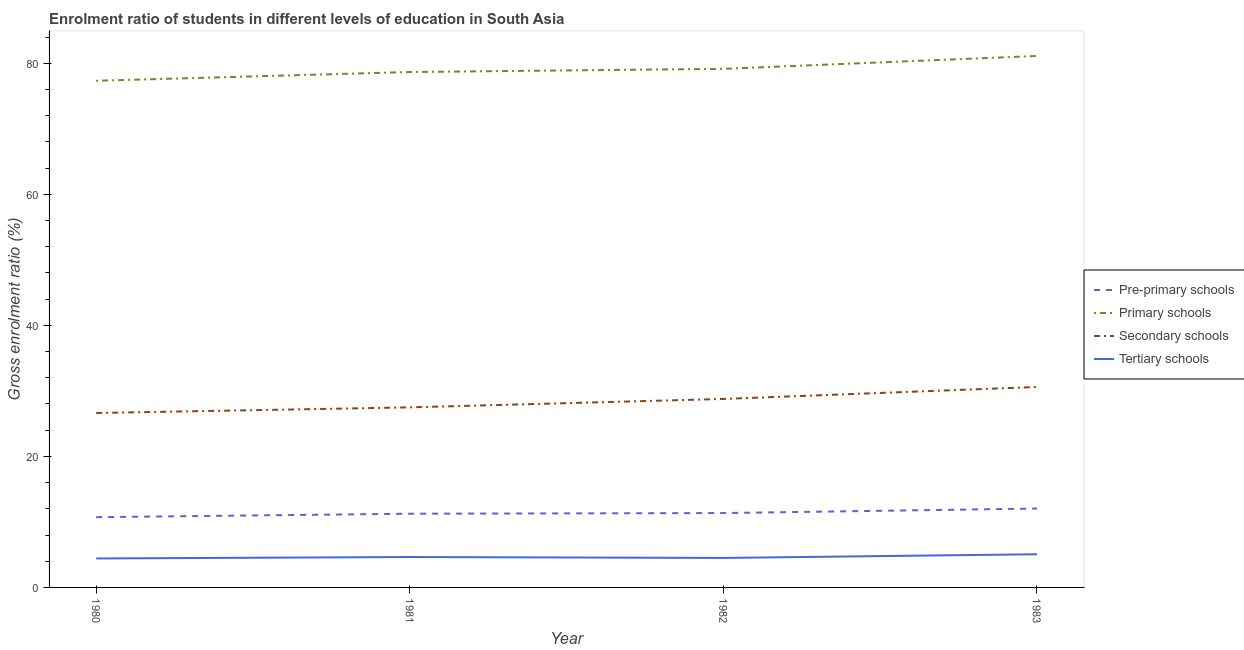Is the number of lines equal to the number of legend labels?
Provide a succinct answer. Yes. What is the gross enrolment ratio in tertiary schools in 1983?
Ensure brevity in your answer.  5.06. Across all years, what is the maximum gross enrolment ratio in primary schools?
Provide a short and direct response. 81.13. Across all years, what is the minimum gross enrolment ratio in secondary schools?
Your answer should be very brief. 26.62. In which year was the gross enrolment ratio in pre-primary schools minimum?
Keep it short and to the point. 1980. What is the total gross enrolment ratio in pre-primary schools in the graph?
Your answer should be very brief. 45.37. What is the difference between the gross enrolment ratio in secondary schools in 1981 and that in 1982?
Give a very brief answer. -1.29. What is the difference between the gross enrolment ratio in pre-primary schools in 1981 and the gross enrolment ratio in tertiary schools in 1980?
Ensure brevity in your answer.  6.83. What is the average gross enrolment ratio in primary schools per year?
Offer a terse response. 79.08. In the year 1981, what is the difference between the gross enrolment ratio in primary schools and gross enrolment ratio in pre-primary schools?
Ensure brevity in your answer.  67.42. In how many years, is the gross enrolment ratio in secondary schools greater than 48 %?
Offer a very short reply. 0. What is the ratio of the gross enrolment ratio in secondary schools in 1981 to that in 1983?
Your answer should be compact. 0.9. Is the difference between the gross enrolment ratio in pre-primary schools in 1980 and 1981 greater than the difference between the gross enrolment ratio in secondary schools in 1980 and 1981?
Make the answer very short. Yes. What is the difference between the highest and the second highest gross enrolment ratio in primary schools?
Offer a very short reply. 1.97. What is the difference between the highest and the lowest gross enrolment ratio in pre-primary schools?
Give a very brief answer. 1.32. Is the sum of the gross enrolment ratio in pre-primary schools in 1980 and 1982 greater than the maximum gross enrolment ratio in primary schools across all years?
Your answer should be compact. No. Is it the case that in every year, the sum of the gross enrolment ratio in pre-primary schools and gross enrolment ratio in primary schools is greater than the gross enrolment ratio in secondary schools?
Your response must be concise. Yes. Is the gross enrolment ratio in secondary schools strictly greater than the gross enrolment ratio in primary schools over the years?
Make the answer very short. No. Is the gross enrolment ratio in pre-primary schools strictly less than the gross enrolment ratio in secondary schools over the years?
Keep it short and to the point. Yes. How many lines are there?
Provide a succinct answer. 4. How many years are there in the graph?
Keep it short and to the point. 4. Are the values on the major ticks of Y-axis written in scientific E-notation?
Give a very brief answer. No. Does the graph contain grids?
Your answer should be compact. No. Where does the legend appear in the graph?
Make the answer very short. Center right. How many legend labels are there?
Your answer should be compact. 4. How are the legend labels stacked?
Your answer should be very brief. Vertical. What is the title of the graph?
Keep it short and to the point. Enrolment ratio of students in different levels of education in South Asia. Does "Source data assessment" appear as one of the legend labels in the graph?
Ensure brevity in your answer.  No. What is the Gross enrolment ratio (%) in Pre-primary schools in 1980?
Offer a very short reply. 10.72. What is the Gross enrolment ratio (%) of Primary schools in 1980?
Your response must be concise. 77.34. What is the Gross enrolment ratio (%) in Secondary schools in 1980?
Your response must be concise. 26.62. What is the Gross enrolment ratio (%) of Tertiary schools in 1980?
Make the answer very short. 4.42. What is the Gross enrolment ratio (%) in Pre-primary schools in 1981?
Ensure brevity in your answer.  11.25. What is the Gross enrolment ratio (%) of Primary schools in 1981?
Your response must be concise. 78.68. What is the Gross enrolment ratio (%) in Secondary schools in 1981?
Make the answer very short. 27.49. What is the Gross enrolment ratio (%) in Tertiary schools in 1981?
Keep it short and to the point. 4.64. What is the Gross enrolment ratio (%) in Pre-primary schools in 1982?
Give a very brief answer. 11.35. What is the Gross enrolment ratio (%) in Primary schools in 1982?
Make the answer very short. 79.16. What is the Gross enrolment ratio (%) in Secondary schools in 1982?
Ensure brevity in your answer.  28.77. What is the Gross enrolment ratio (%) in Tertiary schools in 1982?
Offer a very short reply. 4.5. What is the Gross enrolment ratio (%) in Pre-primary schools in 1983?
Make the answer very short. 12.04. What is the Gross enrolment ratio (%) of Primary schools in 1983?
Keep it short and to the point. 81.13. What is the Gross enrolment ratio (%) of Secondary schools in 1983?
Your response must be concise. 30.6. What is the Gross enrolment ratio (%) in Tertiary schools in 1983?
Provide a short and direct response. 5.06. Across all years, what is the maximum Gross enrolment ratio (%) of Pre-primary schools?
Ensure brevity in your answer.  12.04. Across all years, what is the maximum Gross enrolment ratio (%) in Primary schools?
Offer a terse response. 81.13. Across all years, what is the maximum Gross enrolment ratio (%) of Secondary schools?
Your response must be concise. 30.6. Across all years, what is the maximum Gross enrolment ratio (%) of Tertiary schools?
Your response must be concise. 5.06. Across all years, what is the minimum Gross enrolment ratio (%) in Pre-primary schools?
Offer a very short reply. 10.72. Across all years, what is the minimum Gross enrolment ratio (%) in Primary schools?
Offer a very short reply. 77.34. Across all years, what is the minimum Gross enrolment ratio (%) in Secondary schools?
Provide a succinct answer. 26.62. Across all years, what is the minimum Gross enrolment ratio (%) of Tertiary schools?
Your response must be concise. 4.42. What is the total Gross enrolment ratio (%) in Pre-primary schools in the graph?
Ensure brevity in your answer.  45.37. What is the total Gross enrolment ratio (%) of Primary schools in the graph?
Your answer should be very brief. 316.3. What is the total Gross enrolment ratio (%) of Secondary schools in the graph?
Provide a succinct answer. 113.49. What is the total Gross enrolment ratio (%) in Tertiary schools in the graph?
Offer a very short reply. 18.63. What is the difference between the Gross enrolment ratio (%) of Pre-primary schools in 1980 and that in 1981?
Make the answer very short. -0.53. What is the difference between the Gross enrolment ratio (%) of Primary schools in 1980 and that in 1981?
Your response must be concise. -1.34. What is the difference between the Gross enrolment ratio (%) in Secondary schools in 1980 and that in 1981?
Make the answer very short. -0.86. What is the difference between the Gross enrolment ratio (%) in Tertiary schools in 1980 and that in 1981?
Offer a very short reply. -0.22. What is the difference between the Gross enrolment ratio (%) of Pre-primary schools in 1980 and that in 1982?
Your answer should be compact. -0.63. What is the difference between the Gross enrolment ratio (%) in Primary schools in 1980 and that in 1982?
Make the answer very short. -1.82. What is the difference between the Gross enrolment ratio (%) in Secondary schools in 1980 and that in 1982?
Keep it short and to the point. -2.15. What is the difference between the Gross enrolment ratio (%) of Tertiary schools in 1980 and that in 1982?
Keep it short and to the point. -0.08. What is the difference between the Gross enrolment ratio (%) of Pre-primary schools in 1980 and that in 1983?
Your response must be concise. -1.32. What is the difference between the Gross enrolment ratio (%) in Primary schools in 1980 and that in 1983?
Make the answer very short. -3.79. What is the difference between the Gross enrolment ratio (%) in Secondary schools in 1980 and that in 1983?
Your answer should be very brief. -3.98. What is the difference between the Gross enrolment ratio (%) in Tertiary schools in 1980 and that in 1983?
Offer a terse response. -0.65. What is the difference between the Gross enrolment ratio (%) in Pre-primary schools in 1981 and that in 1982?
Ensure brevity in your answer.  -0.1. What is the difference between the Gross enrolment ratio (%) in Primary schools in 1981 and that in 1982?
Your response must be concise. -0.48. What is the difference between the Gross enrolment ratio (%) of Secondary schools in 1981 and that in 1982?
Give a very brief answer. -1.29. What is the difference between the Gross enrolment ratio (%) in Tertiary schools in 1981 and that in 1982?
Make the answer very short. 0.14. What is the difference between the Gross enrolment ratio (%) in Pre-primary schools in 1981 and that in 1983?
Your response must be concise. -0.79. What is the difference between the Gross enrolment ratio (%) in Primary schools in 1981 and that in 1983?
Give a very brief answer. -2.45. What is the difference between the Gross enrolment ratio (%) of Secondary schools in 1981 and that in 1983?
Keep it short and to the point. -3.12. What is the difference between the Gross enrolment ratio (%) of Tertiary schools in 1981 and that in 1983?
Offer a terse response. -0.42. What is the difference between the Gross enrolment ratio (%) of Pre-primary schools in 1982 and that in 1983?
Give a very brief answer. -0.69. What is the difference between the Gross enrolment ratio (%) in Primary schools in 1982 and that in 1983?
Ensure brevity in your answer.  -1.97. What is the difference between the Gross enrolment ratio (%) of Secondary schools in 1982 and that in 1983?
Your answer should be very brief. -1.83. What is the difference between the Gross enrolment ratio (%) in Tertiary schools in 1982 and that in 1983?
Offer a terse response. -0.56. What is the difference between the Gross enrolment ratio (%) in Pre-primary schools in 1980 and the Gross enrolment ratio (%) in Primary schools in 1981?
Make the answer very short. -67.95. What is the difference between the Gross enrolment ratio (%) of Pre-primary schools in 1980 and the Gross enrolment ratio (%) of Secondary schools in 1981?
Your answer should be compact. -16.76. What is the difference between the Gross enrolment ratio (%) of Pre-primary schools in 1980 and the Gross enrolment ratio (%) of Tertiary schools in 1981?
Your answer should be compact. 6.08. What is the difference between the Gross enrolment ratio (%) in Primary schools in 1980 and the Gross enrolment ratio (%) in Secondary schools in 1981?
Offer a very short reply. 49.85. What is the difference between the Gross enrolment ratio (%) of Primary schools in 1980 and the Gross enrolment ratio (%) of Tertiary schools in 1981?
Keep it short and to the point. 72.7. What is the difference between the Gross enrolment ratio (%) in Secondary schools in 1980 and the Gross enrolment ratio (%) in Tertiary schools in 1981?
Ensure brevity in your answer.  21.98. What is the difference between the Gross enrolment ratio (%) in Pre-primary schools in 1980 and the Gross enrolment ratio (%) in Primary schools in 1982?
Keep it short and to the point. -68.44. What is the difference between the Gross enrolment ratio (%) of Pre-primary schools in 1980 and the Gross enrolment ratio (%) of Secondary schools in 1982?
Offer a very short reply. -18.05. What is the difference between the Gross enrolment ratio (%) of Pre-primary schools in 1980 and the Gross enrolment ratio (%) of Tertiary schools in 1982?
Provide a short and direct response. 6.22. What is the difference between the Gross enrolment ratio (%) in Primary schools in 1980 and the Gross enrolment ratio (%) in Secondary schools in 1982?
Your response must be concise. 48.57. What is the difference between the Gross enrolment ratio (%) of Primary schools in 1980 and the Gross enrolment ratio (%) of Tertiary schools in 1982?
Give a very brief answer. 72.84. What is the difference between the Gross enrolment ratio (%) of Secondary schools in 1980 and the Gross enrolment ratio (%) of Tertiary schools in 1982?
Offer a terse response. 22.12. What is the difference between the Gross enrolment ratio (%) in Pre-primary schools in 1980 and the Gross enrolment ratio (%) in Primary schools in 1983?
Provide a short and direct response. -70.41. What is the difference between the Gross enrolment ratio (%) of Pre-primary schools in 1980 and the Gross enrolment ratio (%) of Secondary schools in 1983?
Offer a terse response. -19.88. What is the difference between the Gross enrolment ratio (%) of Pre-primary schools in 1980 and the Gross enrolment ratio (%) of Tertiary schools in 1983?
Offer a terse response. 5.66. What is the difference between the Gross enrolment ratio (%) in Primary schools in 1980 and the Gross enrolment ratio (%) in Secondary schools in 1983?
Make the answer very short. 46.74. What is the difference between the Gross enrolment ratio (%) in Primary schools in 1980 and the Gross enrolment ratio (%) in Tertiary schools in 1983?
Offer a terse response. 72.27. What is the difference between the Gross enrolment ratio (%) of Secondary schools in 1980 and the Gross enrolment ratio (%) of Tertiary schools in 1983?
Keep it short and to the point. 21.56. What is the difference between the Gross enrolment ratio (%) in Pre-primary schools in 1981 and the Gross enrolment ratio (%) in Primary schools in 1982?
Ensure brevity in your answer.  -67.91. What is the difference between the Gross enrolment ratio (%) of Pre-primary schools in 1981 and the Gross enrolment ratio (%) of Secondary schools in 1982?
Ensure brevity in your answer.  -17.52. What is the difference between the Gross enrolment ratio (%) of Pre-primary schools in 1981 and the Gross enrolment ratio (%) of Tertiary schools in 1982?
Offer a very short reply. 6.75. What is the difference between the Gross enrolment ratio (%) in Primary schools in 1981 and the Gross enrolment ratio (%) in Secondary schools in 1982?
Your response must be concise. 49.9. What is the difference between the Gross enrolment ratio (%) in Primary schools in 1981 and the Gross enrolment ratio (%) in Tertiary schools in 1982?
Ensure brevity in your answer.  74.18. What is the difference between the Gross enrolment ratio (%) in Secondary schools in 1981 and the Gross enrolment ratio (%) in Tertiary schools in 1982?
Offer a terse response. 22.99. What is the difference between the Gross enrolment ratio (%) in Pre-primary schools in 1981 and the Gross enrolment ratio (%) in Primary schools in 1983?
Ensure brevity in your answer.  -69.87. What is the difference between the Gross enrolment ratio (%) in Pre-primary schools in 1981 and the Gross enrolment ratio (%) in Secondary schools in 1983?
Give a very brief answer. -19.35. What is the difference between the Gross enrolment ratio (%) in Pre-primary schools in 1981 and the Gross enrolment ratio (%) in Tertiary schools in 1983?
Make the answer very short. 6.19. What is the difference between the Gross enrolment ratio (%) of Primary schools in 1981 and the Gross enrolment ratio (%) of Secondary schools in 1983?
Your answer should be compact. 48.07. What is the difference between the Gross enrolment ratio (%) of Primary schools in 1981 and the Gross enrolment ratio (%) of Tertiary schools in 1983?
Ensure brevity in your answer.  73.61. What is the difference between the Gross enrolment ratio (%) in Secondary schools in 1981 and the Gross enrolment ratio (%) in Tertiary schools in 1983?
Your answer should be very brief. 22.42. What is the difference between the Gross enrolment ratio (%) of Pre-primary schools in 1982 and the Gross enrolment ratio (%) of Primary schools in 1983?
Provide a short and direct response. -69.78. What is the difference between the Gross enrolment ratio (%) in Pre-primary schools in 1982 and the Gross enrolment ratio (%) in Secondary schools in 1983?
Offer a terse response. -19.25. What is the difference between the Gross enrolment ratio (%) of Pre-primary schools in 1982 and the Gross enrolment ratio (%) of Tertiary schools in 1983?
Your answer should be very brief. 6.29. What is the difference between the Gross enrolment ratio (%) in Primary schools in 1982 and the Gross enrolment ratio (%) in Secondary schools in 1983?
Offer a terse response. 48.56. What is the difference between the Gross enrolment ratio (%) in Primary schools in 1982 and the Gross enrolment ratio (%) in Tertiary schools in 1983?
Your answer should be very brief. 74.1. What is the difference between the Gross enrolment ratio (%) in Secondary schools in 1982 and the Gross enrolment ratio (%) in Tertiary schools in 1983?
Provide a succinct answer. 23.71. What is the average Gross enrolment ratio (%) of Pre-primary schools per year?
Provide a short and direct response. 11.34. What is the average Gross enrolment ratio (%) of Primary schools per year?
Keep it short and to the point. 79.08. What is the average Gross enrolment ratio (%) of Secondary schools per year?
Provide a short and direct response. 28.37. What is the average Gross enrolment ratio (%) of Tertiary schools per year?
Provide a short and direct response. 4.66. In the year 1980, what is the difference between the Gross enrolment ratio (%) in Pre-primary schools and Gross enrolment ratio (%) in Primary schools?
Your answer should be compact. -66.62. In the year 1980, what is the difference between the Gross enrolment ratio (%) in Pre-primary schools and Gross enrolment ratio (%) in Secondary schools?
Your answer should be very brief. -15.9. In the year 1980, what is the difference between the Gross enrolment ratio (%) of Pre-primary schools and Gross enrolment ratio (%) of Tertiary schools?
Provide a succinct answer. 6.3. In the year 1980, what is the difference between the Gross enrolment ratio (%) in Primary schools and Gross enrolment ratio (%) in Secondary schools?
Keep it short and to the point. 50.71. In the year 1980, what is the difference between the Gross enrolment ratio (%) of Primary schools and Gross enrolment ratio (%) of Tertiary schools?
Provide a short and direct response. 72.92. In the year 1980, what is the difference between the Gross enrolment ratio (%) of Secondary schools and Gross enrolment ratio (%) of Tertiary schools?
Your response must be concise. 22.21. In the year 1981, what is the difference between the Gross enrolment ratio (%) of Pre-primary schools and Gross enrolment ratio (%) of Primary schools?
Make the answer very short. -67.42. In the year 1981, what is the difference between the Gross enrolment ratio (%) in Pre-primary schools and Gross enrolment ratio (%) in Secondary schools?
Ensure brevity in your answer.  -16.23. In the year 1981, what is the difference between the Gross enrolment ratio (%) in Pre-primary schools and Gross enrolment ratio (%) in Tertiary schools?
Offer a terse response. 6.61. In the year 1981, what is the difference between the Gross enrolment ratio (%) in Primary schools and Gross enrolment ratio (%) in Secondary schools?
Ensure brevity in your answer.  51.19. In the year 1981, what is the difference between the Gross enrolment ratio (%) in Primary schools and Gross enrolment ratio (%) in Tertiary schools?
Your answer should be very brief. 74.03. In the year 1981, what is the difference between the Gross enrolment ratio (%) in Secondary schools and Gross enrolment ratio (%) in Tertiary schools?
Make the answer very short. 22.84. In the year 1982, what is the difference between the Gross enrolment ratio (%) in Pre-primary schools and Gross enrolment ratio (%) in Primary schools?
Give a very brief answer. -67.81. In the year 1982, what is the difference between the Gross enrolment ratio (%) in Pre-primary schools and Gross enrolment ratio (%) in Secondary schools?
Provide a succinct answer. -17.42. In the year 1982, what is the difference between the Gross enrolment ratio (%) in Pre-primary schools and Gross enrolment ratio (%) in Tertiary schools?
Offer a very short reply. 6.85. In the year 1982, what is the difference between the Gross enrolment ratio (%) of Primary schools and Gross enrolment ratio (%) of Secondary schools?
Offer a very short reply. 50.39. In the year 1982, what is the difference between the Gross enrolment ratio (%) in Primary schools and Gross enrolment ratio (%) in Tertiary schools?
Provide a succinct answer. 74.66. In the year 1982, what is the difference between the Gross enrolment ratio (%) in Secondary schools and Gross enrolment ratio (%) in Tertiary schools?
Offer a terse response. 24.27. In the year 1983, what is the difference between the Gross enrolment ratio (%) of Pre-primary schools and Gross enrolment ratio (%) of Primary schools?
Your answer should be very brief. -69.09. In the year 1983, what is the difference between the Gross enrolment ratio (%) in Pre-primary schools and Gross enrolment ratio (%) in Secondary schools?
Make the answer very short. -18.56. In the year 1983, what is the difference between the Gross enrolment ratio (%) in Pre-primary schools and Gross enrolment ratio (%) in Tertiary schools?
Your answer should be very brief. 6.98. In the year 1983, what is the difference between the Gross enrolment ratio (%) of Primary schools and Gross enrolment ratio (%) of Secondary schools?
Offer a very short reply. 50.53. In the year 1983, what is the difference between the Gross enrolment ratio (%) of Primary schools and Gross enrolment ratio (%) of Tertiary schools?
Offer a terse response. 76.06. In the year 1983, what is the difference between the Gross enrolment ratio (%) of Secondary schools and Gross enrolment ratio (%) of Tertiary schools?
Provide a short and direct response. 25.54. What is the ratio of the Gross enrolment ratio (%) in Pre-primary schools in 1980 to that in 1981?
Offer a very short reply. 0.95. What is the ratio of the Gross enrolment ratio (%) of Secondary schools in 1980 to that in 1981?
Make the answer very short. 0.97. What is the ratio of the Gross enrolment ratio (%) of Tertiary schools in 1980 to that in 1981?
Provide a short and direct response. 0.95. What is the ratio of the Gross enrolment ratio (%) in Pre-primary schools in 1980 to that in 1982?
Make the answer very short. 0.94. What is the ratio of the Gross enrolment ratio (%) in Secondary schools in 1980 to that in 1982?
Ensure brevity in your answer.  0.93. What is the ratio of the Gross enrolment ratio (%) in Tertiary schools in 1980 to that in 1982?
Make the answer very short. 0.98. What is the ratio of the Gross enrolment ratio (%) of Pre-primary schools in 1980 to that in 1983?
Provide a succinct answer. 0.89. What is the ratio of the Gross enrolment ratio (%) of Primary schools in 1980 to that in 1983?
Provide a succinct answer. 0.95. What is the ratio of the Gross enrolment ratio (%) of Secondary schools in 1980 to that in 1983?
Provide a short and direct response. 0.87. What is the ratio of the Gross enrolment ratio (%) in Tertiary schools in 1980 to that in 1983?
Your response must be concise. 0.87. What is the ratio of the Gross enrolment ratio (%) of Pre-primary schools in 1981 to that in 1982?
Ensure brevity in your answer.  0.99. What is the ratio of the Gross enrolment ratio (%) in Primary schools in 1981 to that in 1982?
Your answer should be very brief. 0.99. What is the ratio of the Gross enrolment ratio (%) in Secondary schools in 1981 to that in 1982?
Provide a succinct answer. 0.96. What is the ratio of the Gross enrolment ratio (%) in Tertiary schools in 1981 to that in 1982?
Your answer should be very brief. 1.03. What is the ratio of the Gross enrolment ratio (%) of Pre-primary schools in 1981 to that in 1983?
Make the answer very short. 0.93. What is the ratio of the Gross enrolment ratio (%) of Primary schools in 1981 to that in 1983?
Offer a terse response. 0.97. What is the ratio of the Gross enrolment ratio (%) of Secondary schools in 1981 to that in 1983?
Offer a very short reply. 0.9. What is the ratio of the Gross enrolment ratio (%) in Tertiary schools in 1981 to that in 1983?
Provide a short and direct response. 0.92. What is the ratio of the Gross enrolment ratio (%) of Pre-primary schools in 1982 to that in 1983?
Your answer should be compact. 0.94. What is the ratio of the Gross enrolment ratio (%) in Primary schools in 1982 to that in 1983?
Provide a succinct answer. 0.98. What is the ratio of the Gross enrolment ratio (%) in Secondary schools in 1982 to that in 1983?
Give a very brief answer. 0.94. What is the ratio of the Gross enrolment ratio (%) in Tertiary schools in 1982 to that in 1983?
Provide a short and direct response. 0.89. What is the difference between the highest and the second highest Gross enrolment ratio (%) in Pre-primary schools?
Your response must be concise. 0.69. What is the difference between the highest and the second highest Gross enrolment ratio (%) of Primary schools?
Keep it short and to the point. 1.97. What is the difference between the highest and the second highest Gross enrolment ratio (%) in Secondary schools?
Keep it short and to the point. 1.83. What is the difference between the highest and the second highest Gross enrolment ratio (%) of Tertiary schools?
Offer a terse response. 0.42. What is the difference between the highest and the lowest Gross enrolment ratio (%) of Pre-primary schools?
Ensure brevity in your answer.  1.32. What is the difference between the highest and the lowest Gross enrolment ratio (%) in Primary schools?
Give a very brief answer. 3.79. What is the difference between the highest and the lowest Gross enrolment ratio (%) in Secondary schools?
Ensure brevity in your answer.  3.98. What is the difference between the highest and the lowest Gross enrolment ratio (%) of Tertiary schools?
Make the answer very short. 0.65. 